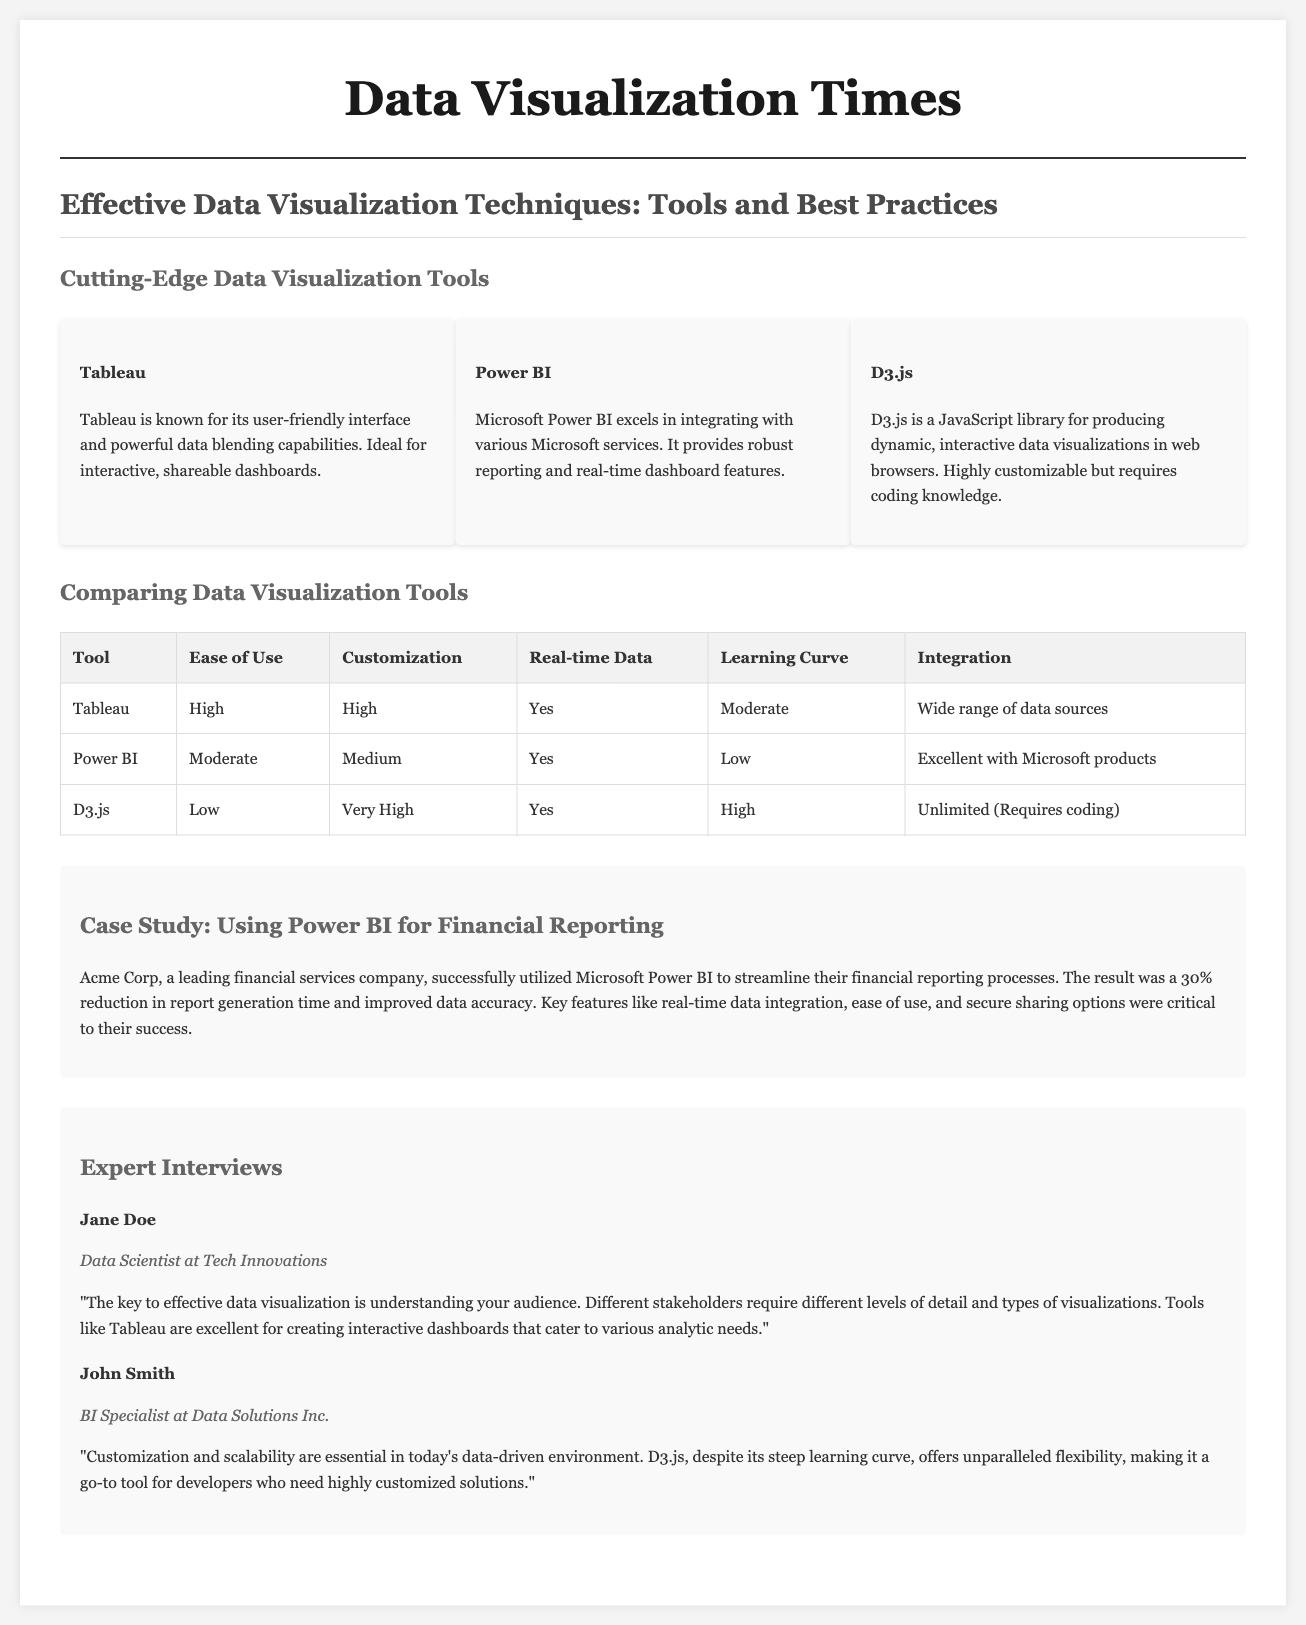what is the title of the feature story? The title is prominently displayed as the main heading of the article.
Answer: Effective Data Visualization Techniques: Tools and Best Practices how many data visualization tools are mentioned? There are three data visualization tools highlighted in a specific section of the document.
Answer: Three which tool is known for its user-friendly interface? The document describes one of the tools specifically stating that it is known for this characteristic.
Answer: Tableau what percentage reduction in report generation time did Acme Corp achieve? The case study section provides specific performance results from using a particular tool.
Answer: 30% who is quoted as a BI Specialist at Data Solutions Inc.? The document includes names and roles of various experts in the interviews section.
Answer: John Smith what is the main benefit of using D3.js according to the expert? The expert discusses a key advantage regarding the capabilities of this tool.
Answer: Customization and scalability which tool provides excellent integration with Microsoft products? The comparison chart highlights specific integration capabilities of different tools.
Answer: Power BI what learning curve is associated with D3.js? The comparison table includes ratings for ease of use and learning curves for each tool, indicating D3.js's level.
Answer: High 